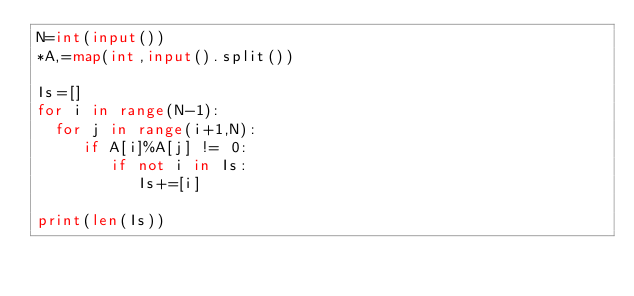<code> <loc_0><loc_0><loc_500><loc_500><_Python_>N=int(input())
*A,=map(int,input().split())

Is=[]
for i in range(N-1):
  for j in range(i+1,N):
     if A[i]%A[j] != 0:
        if not i in Is:
           Is+=[i]
            
print(len(Is))
</code> 